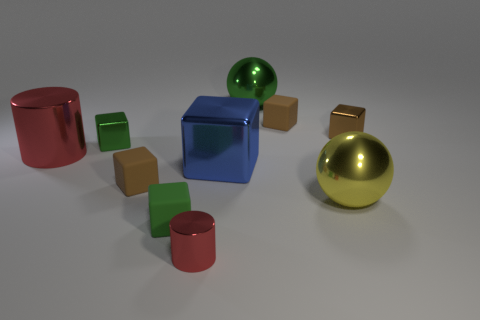The other cylinder that is the same color as the big shiny cylinder is what size?
Keep it short and to the point. Small. How many red objects are big metal cylinders or cubes?
Your response must be concise. 1. What color is the big shiny cube?
Your answer should be very brief. Blue. The sphere that is the same material as the big yellow object is what size?
Give a very brief answer. Large. How many yellow metallic things are the same shape as the tiny red object?
Give a very brief answer. 0. Are there any other things that are the same size as the green matte thing?
Keep it short and to the point. Yes. There is a rubber block that is to the right of the green object that is right of the small red cylinder; what is its size?
Make the answer very short. Small. What is the material of the red cylinder that is the same size as the green sphere?
Keep it short and to the point. Metal. Are there any brown things that have the same material as the green ball?
Keep it short and to the point. Yes. The large sphere in front of the big metallic ball on the left side of the large shiny sphere in front of the brown shiny block is what color?
Ensure brevity in your answer.  Yellow. 